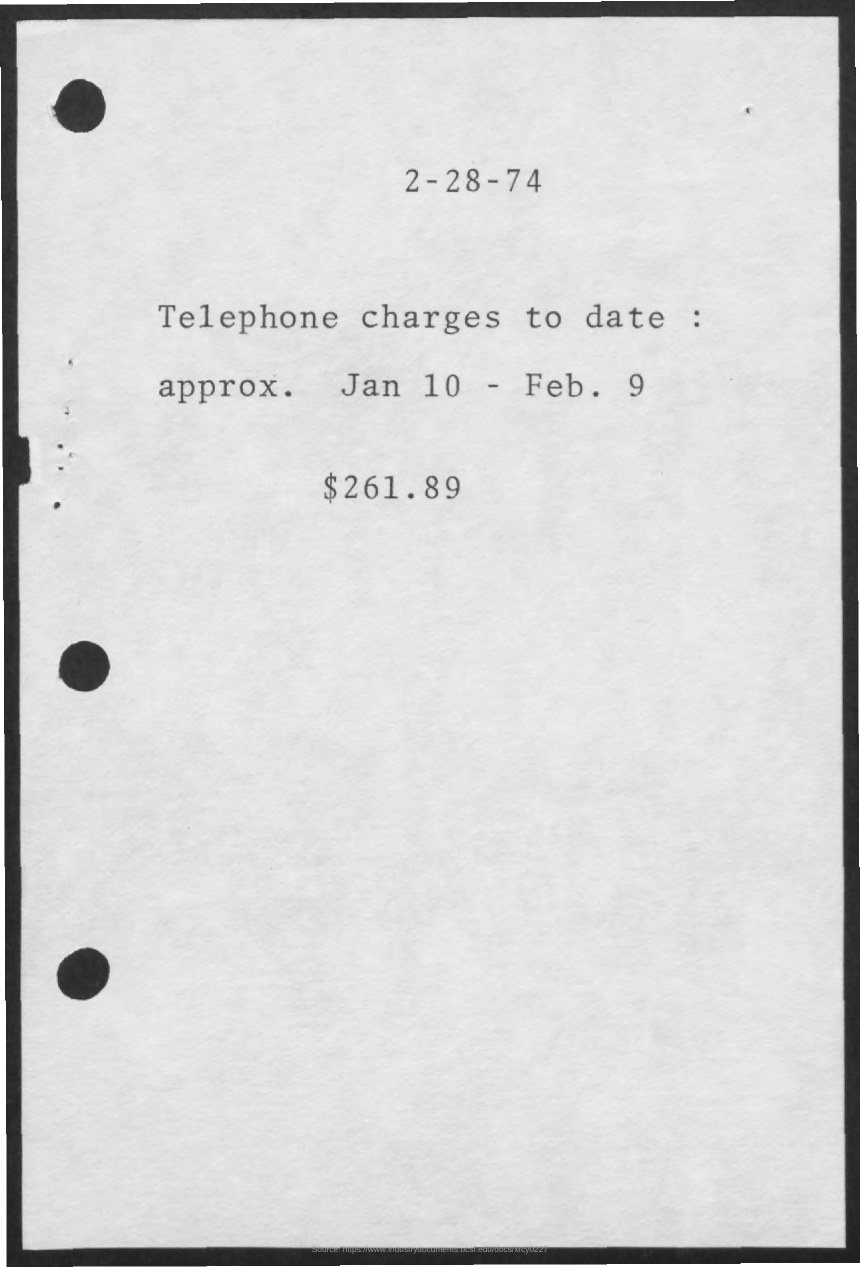List a handful of essential elements in this visual. The total charge for telephone services is $261.89. The date of the document is February 28, 1974. The document is concerned with telephone charges. 